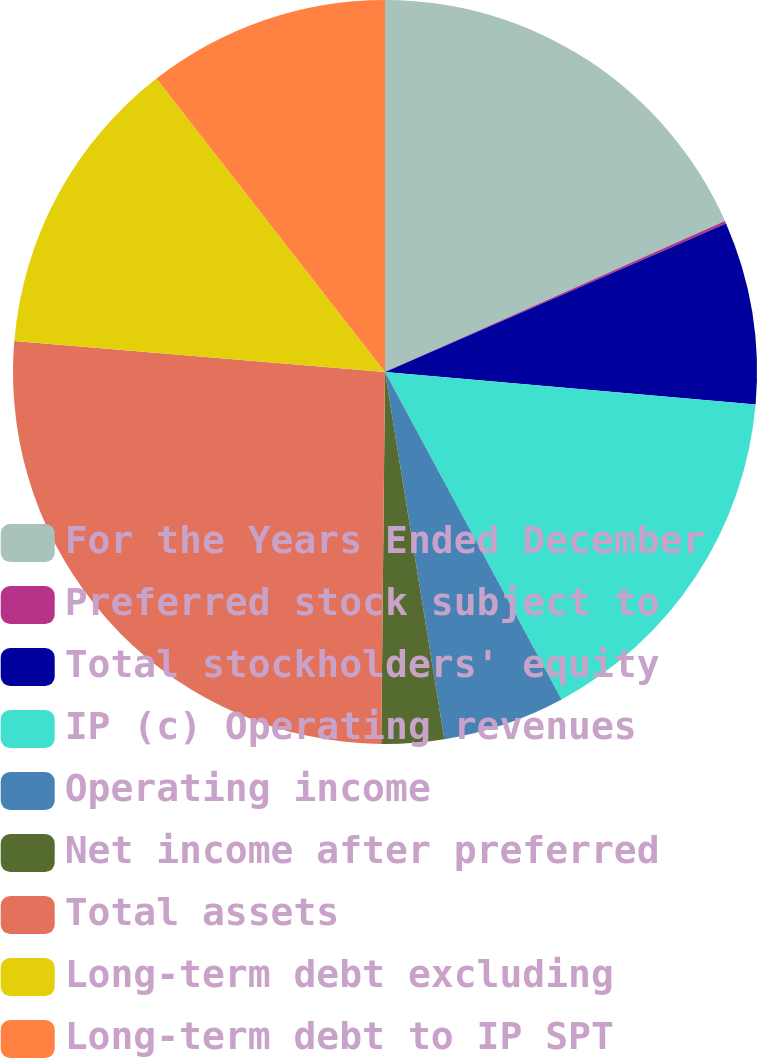<chart> <loc_0><loc_0><loc_500><loc_500><pie_chart><fcel>For the Years Ended December<fcel>Preferred stock subject to<fcel>Total stockholders' equity<fcel>IP (c) Operating revenues<fcel>Operating income<fcel>Net income after preferred<fcel>Total assets<fcel>Long-term debt excluding<fcel>Long-term debt to IP SPT<nl><fcel>18.35%<fcel>0.11%<fcel>7.93%<fcel>15.74%<fcel>5.32%<fcel>2.71%<fcel>26.17%<fcel>13.14%<fcel>10.53%<nl></chart> 